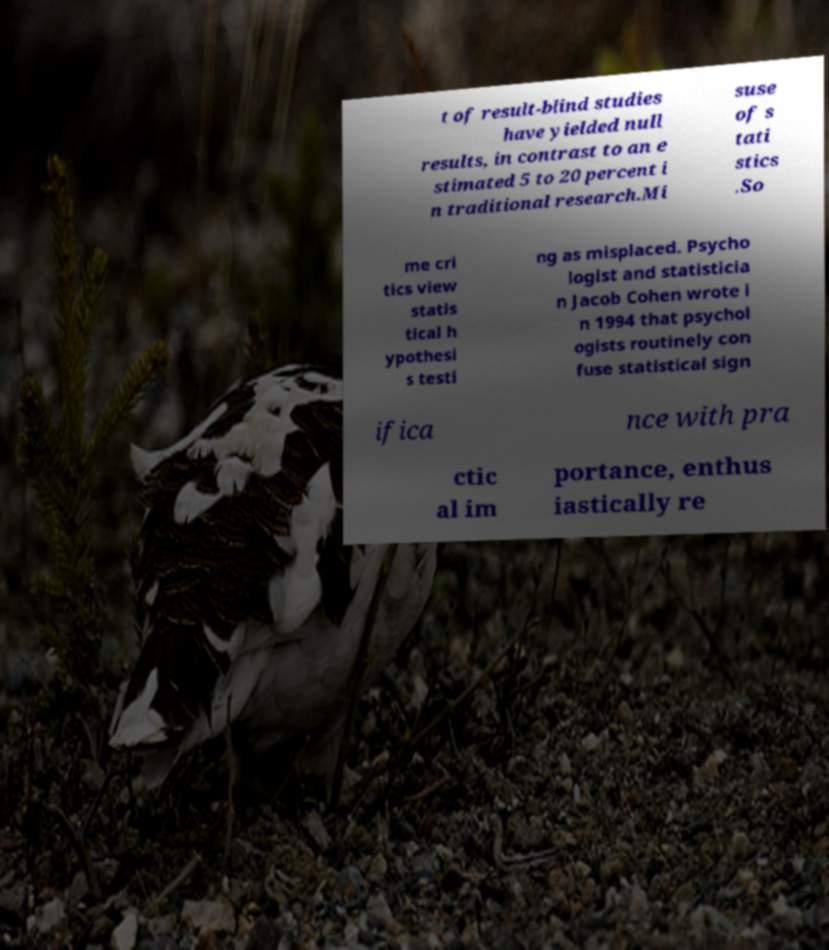Could you assist in decoding the text presented in this image and type it out clearly? t of result-blind studies have yielded null results, in contrast to an e stimated 5 to 20 percent i n traditional research.Mi suse of s tati stics .So me cri tics view statis tical h ypothesi s testi ng as misplaced. Psycho logist and statisticia n Jacob Cohen wrote i n 1994 that psychol ogists routinely con fuse statistical sign ifica nce with pra ctic al im portance, enthus iastically re 